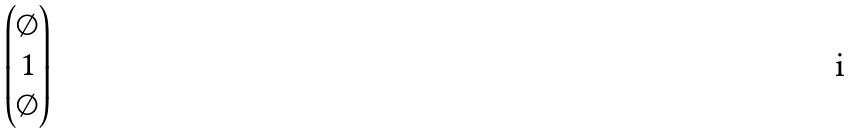<formula> <loc_0><loc_0><loc_500><loc_500>\begin{pmatrix} \emptyset \\ 1 \\ \emptyset \end{pmatrix}</formula> 